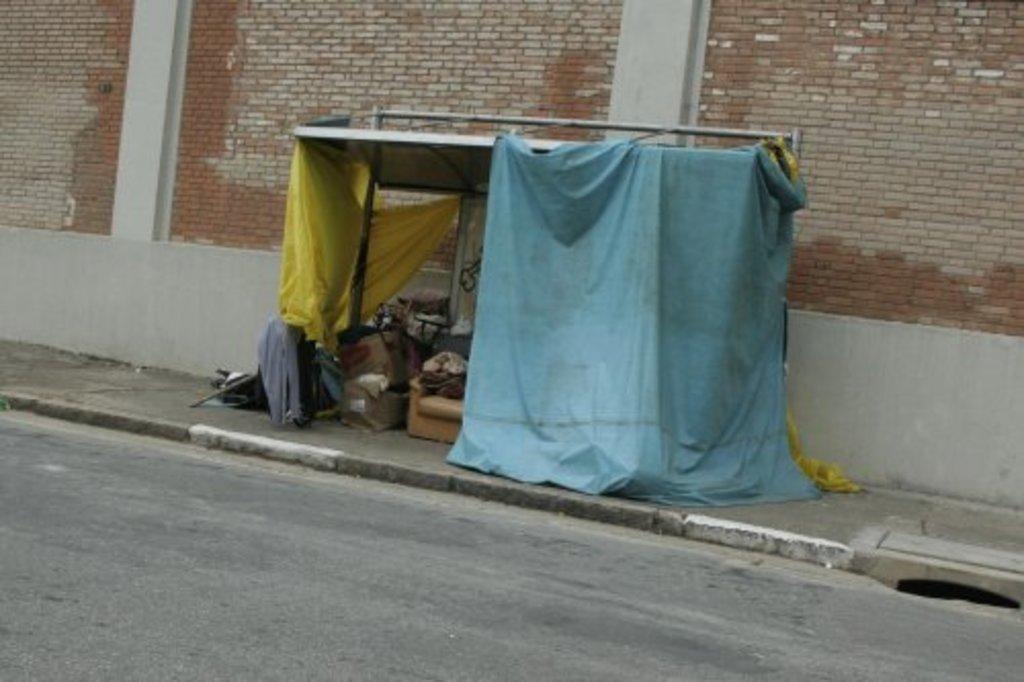Describe this image in one or two sentences. In this image we can see a shed and there are things placed in the shed. At the bottom there is a road. In the background there is a wall. 